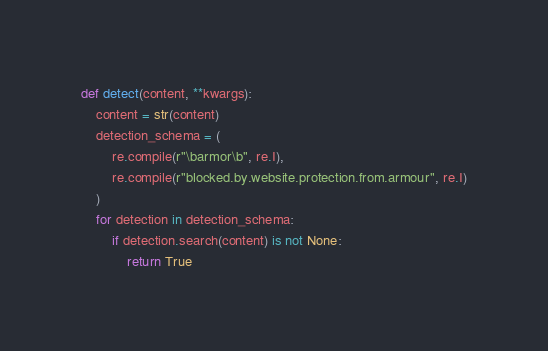<code> <loc_0><loc_0><loc_500><loc_500><_Python_>
def detect(content, **kwargs):
    content = str(content)
    detection_schema = (
        re.compile(r"\barmor\b", re.I),
        re.compile(r"blocked.by.website.protection.from.armour", re.I)
    )
    for detection in detection_schema:
        if detection.search(content) is not None:
            return True</code> 